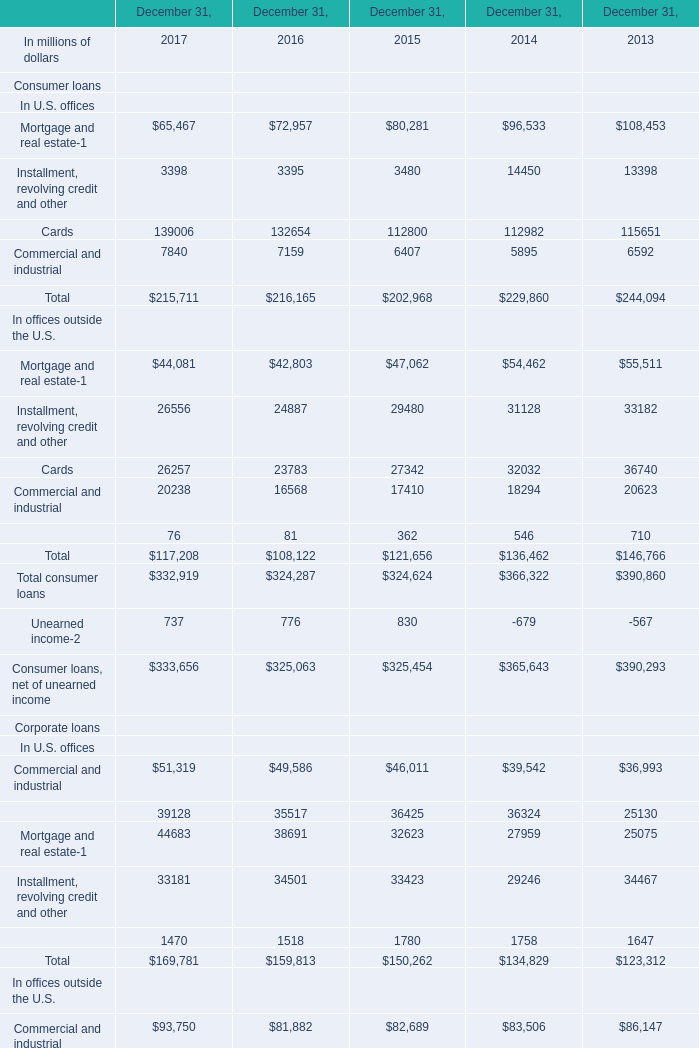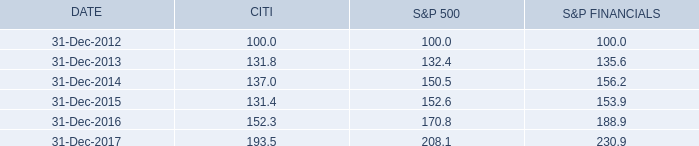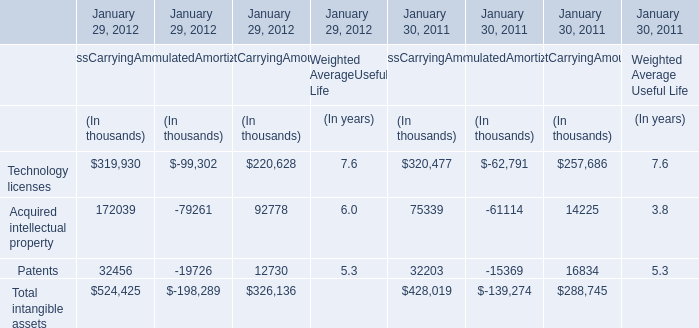What's the current increasing rate of Total corporate loans? (in million) 
Computations: ((334141 - 300010) / 300010)
Answer: 0.11377. 